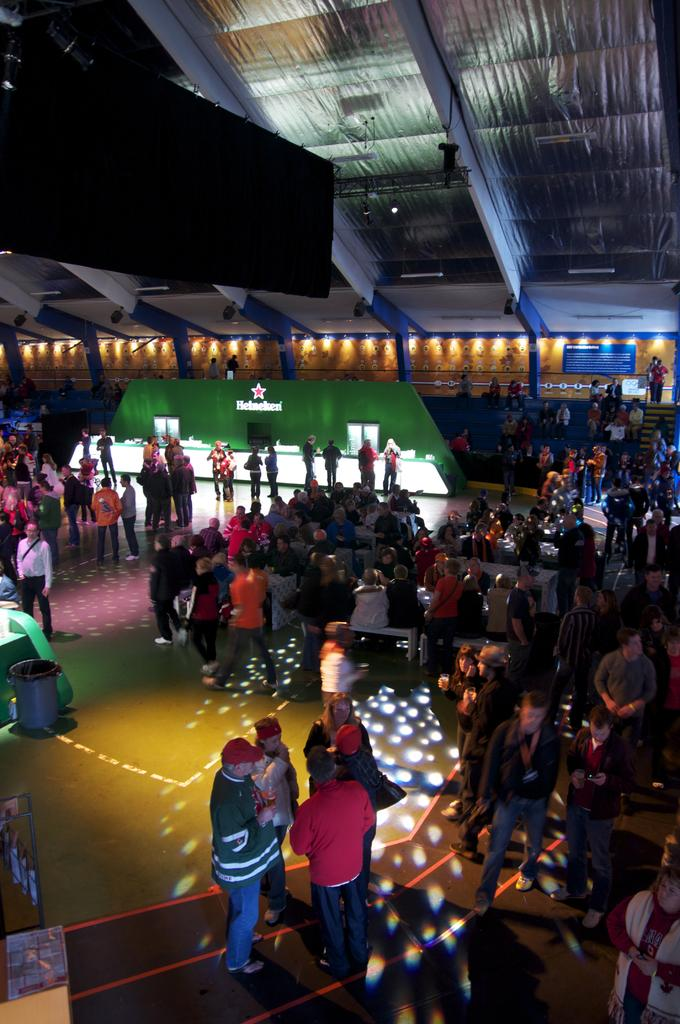What can be seen on the right side of the image? There are people on the right side of the image. What can be seen on the left side of the image? There are people on the left side of the image. What is located in the center of the image? There are spotlights in the center of the image. What is at the top side of the image? There is a roof at the top side of the image. What type of flowers are being used to help the people on the left side of the image? There are no flowers present in the image, and the people on the left side do not require any assistance from flowers. 